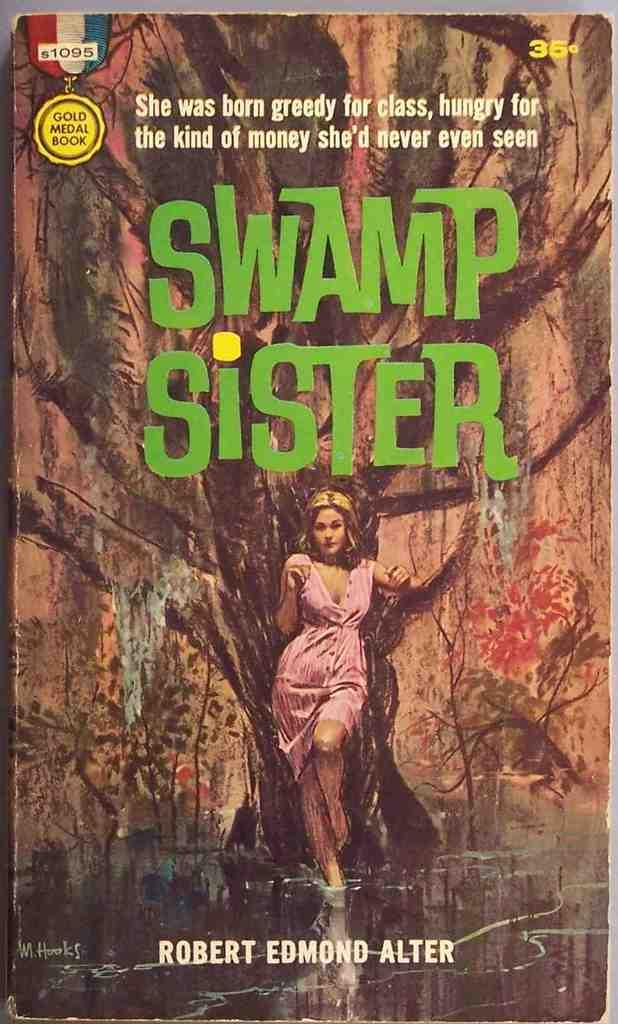<image>
Present a compact description of the photo's key features. A front cover of the book Swamp Sister by Robert Edmond Alter 